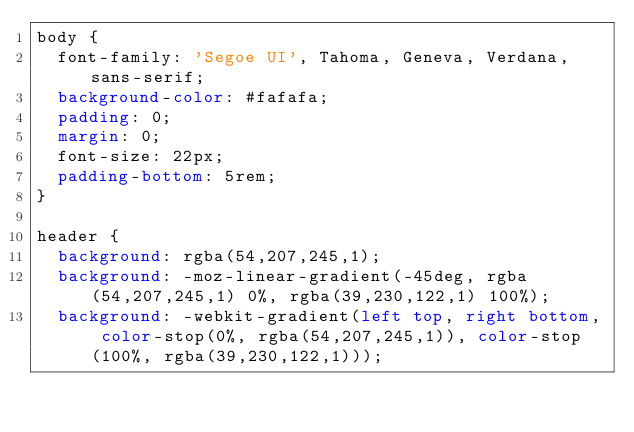<code> <loc_0><loc_0><loc_500><loc_500><_CSS_>body {
  font-family: 'Segoe UI', Tahoma, Geneva, Verdana, sans-serif;
  background-color: #fafafa;
  padding: 0;
  margin: 0;
  font-size: 22px;
  padding-bottom: 5rem;
}

header {
  background: rgba(54,207,245,1);
  background: -moz-linear-gradient(-45deg, rgba(54,207,245,1) 0%, rgba(39,230,122,1) 100%);
  background: -webkit-gradient(left top, right bottom, color-stop(0%, rgba(54,207,245,1)), color-stop(100%, rgba(39,230,122,1)));</code> 